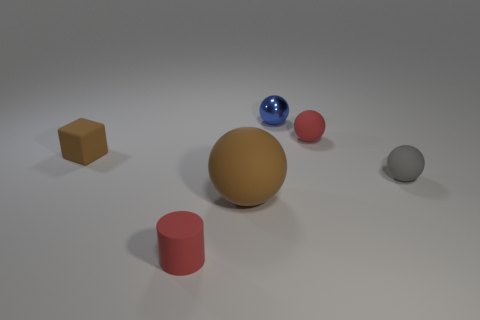Subtract all cyan spheres. Subtract all green blocks. How many spheres are left? 4 Add 3 small green matte objects. How many objects exist? 9 Subtract all cylinders. How many objects are left? 5 Add 4 small green metal blocks. How many small green metal blocks exist? 4 Subtract 1 red spheres. How many objects are left? 5 Subtract all big spheres. Subtract all rubber things. How many objects are left? 0 Add 6 small red rubber cylinders. How many small red rubber cylinders are left? 7 